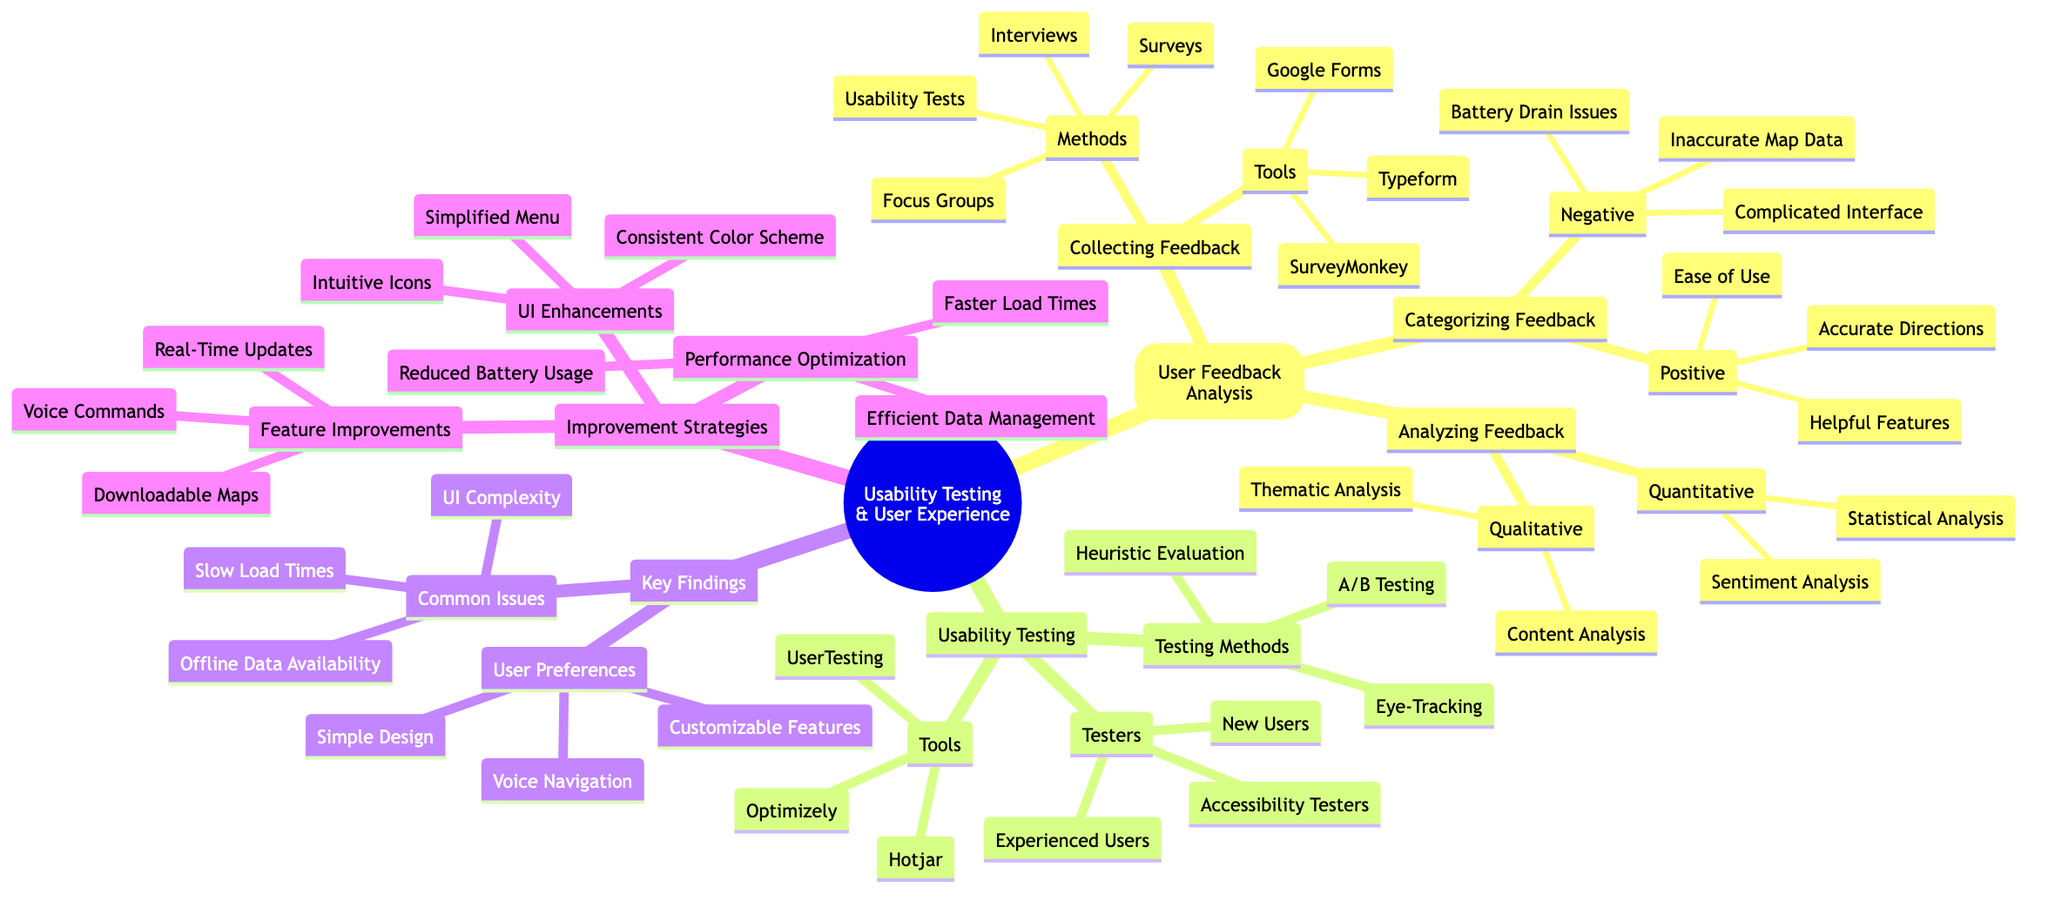What methods are used for collecting feedback? The diagram specifies that methods for collecting feedback include Surveys, Interviews, Focus Groups, and Usability Tests, all of which are listed under the "Collecting Feedback" node.
Answer: Surveys, Interviews, Focus Groups, Usability Tests What are the positive aspects of user feedback? Under the "Categorizing Feedback" section, the positive feedback is labeled and includes Ease of Use, Accurate Directions, and Helpful Features.
Answer: Ease of Use, Accurate Directions, Helpful Features How many testing methods are listed in the usability testing section? By counting the items listed under the "Testing Methods" node, which includes A/B Testing, Heuristic Evaluation, and Eye-Tracking, there are a total of three methods.
Answer: 3 Which user preferences are highlighted in the findings? The diagram shows under the "User Preferences" section that the highlighted preferences are Simple Design, Customizable Features, and Voice Navigation.
Answer: Simple Design, Customizable Features, Voice Navigation What is one common issue noted in the key findings? The "Common Issues" portion reveals UI Complexity, Slow Load Times, and Offline Data Availability as prevalent issues, so selecting any of these would answer the question.
Answer: UI Complexity What tools are used for usability testing? The "Tools" section under usability testing includes Optimizely, Hotjar, and UserTesting, which makes up the full list utilized in this context.
Answer: Optimizely, Hotjar, UserTesting What are two improvement strategies for UI enhancements? Within the "Improvement Strategies" section, the node "UI Enhancements" lists Simplified Menu, Intuitive Icons, and Consistent Color Scheme, allowing for multiple combinations but focusing on identifying any two.
Answer: Simplified Menu, Intuitive Icons Which qualitative analysis techniques are mentioned in the diagram? The "Analyzing Feedback" node specifies that Qualitative Analysis includes Thematic Analysis and Content Analysis, thus both are part of the answer.
Answer: Thematic Analysis, Content Analysis How do performance optimizations aim to improve the user experience? The "Performance Optimization" section mentions Faster Load Times, Efficient Data Management, and Reduced Battery Usage, indicating the key areas targeted for improving user experience.
Answer: Faster Load Times, Efficient Data Management, Reduced Battery Usage 